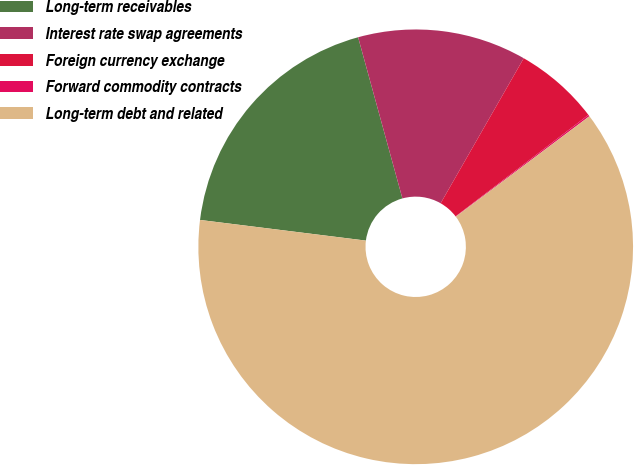Convert chart to OTSL. <chart><loc_0><loc_0><loc_500><loc_500><pie_chart><fcel>Long-term receivables<fcel>Interest rate swap agreements<fcel>Foreign currency exchange<fcel>Forward commodity contracts<fcel>Long-term debt and related<nl><fcel>18.76%<fcel>12.55%<fcel>6.34%<fcel>0.12%<fcel>62.24%<nl></chart> 